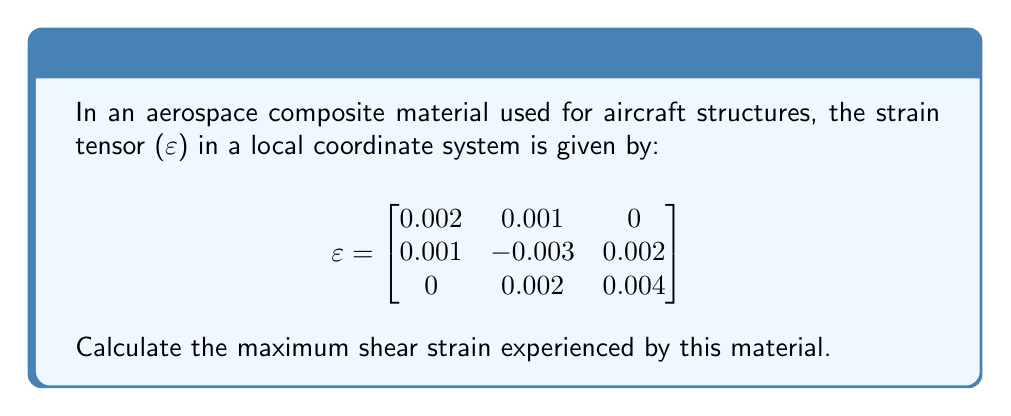Could you help me with this problem? To find the maximum shear strain, we need to follow these steps:

1) The maximum shear strain is given by the formula:
   $$\gamma_{max} = \sqrt{(\varepsilon_1 - \varepsilon_3)^2 + 4(\gamma_{12}^2 + \gamma_{23}^2 + \gamma_{31}^2)}$$
   where $\varepsilon_1$, $\varepsilon_2$, and $\varepsilon_3$ are the principal strains, and $\gamma_{12}$, $\gamma_{23}$, and $\gamma_{31}$ are the engineering shear strains.

2) To find the principal strains, we need to solve the characteristic equation:
   $$det(\varepsilon - \lambda I) = 0$$

3) Expanding this determinant:
   $$\begin{vmatrix}
   0.002 - \lambda & 0.001 & 0 \\
   0.001 & -0.003 - \lambda & 0.002 \\
   0 & 0.002 & 0.004 - \lambda
   \end{vmatrix} = 0$$

4) This leads to the cubic equation:
   $$-\lambda^3 + 0.003\lambda^2 + 0.000013\lambda - 0.0000002 = 0$$

5) Solving this equation (using a calculator or computer algebra system) gives:
   $\varepsilon_1 = 0.00435$, $\varepsilon_2 = 0.00263$, $\varepsilon_3 = -0.00398$

6) The engineering shear strains are twice the corresponding tensor components:
   $\gamma_{12} = 2(0.001) = 0.002$
   $\gamma_{23} = 2(0.002) = 0.004$
   $\gamma_{31} = 2(0) = 0$

7) Substituting into the maximum shear strain formula:
   $$\gamma_{max} = \sqrt{(0.00435 - (-0.00398))^2 + 4(0.002^2 + 0.004^2 + 0^2)}$$

8) Simplifying:
   $$\gamma_{max} = \sqrt{0.00833^2 + 4(0.000004 + 0.000016)}$$
   $$\gamma_{max} = \sqrt{0.0000694 + 0.00008} = \sqrt{0.0001494} = 0.0122$$

Therefore, the maximum shear strain is approximately 0.0122 or 1.22%.
Answer: 0.0122 